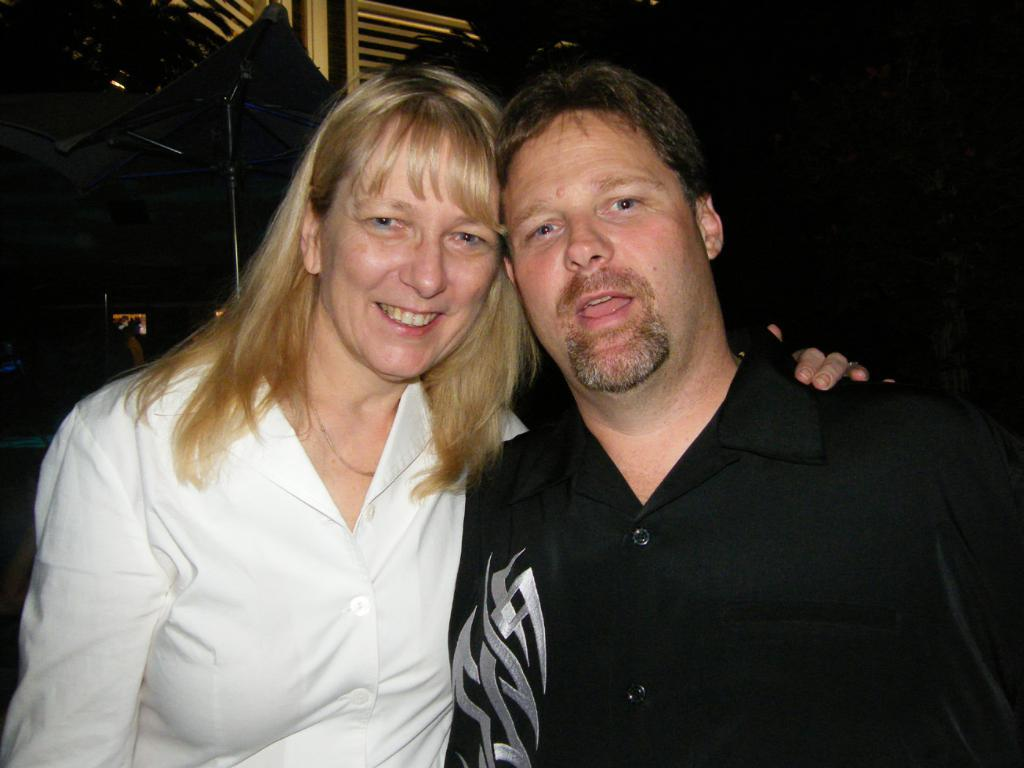How many people are in the image? There is a woman and a man in the image. What can be seen in the background of the image? The background of the image is dark. What object is present to provide shelter from the elements? There is an umbrella in the image. What structure is visible in the image? There is a stand in the image. What type of architectural feature is present in the image? There are grilles in the image. What type of fruit is the woman holding in the image? There is no fruit visible in the image. What type of army is present in the image? There is no army present in the image. 